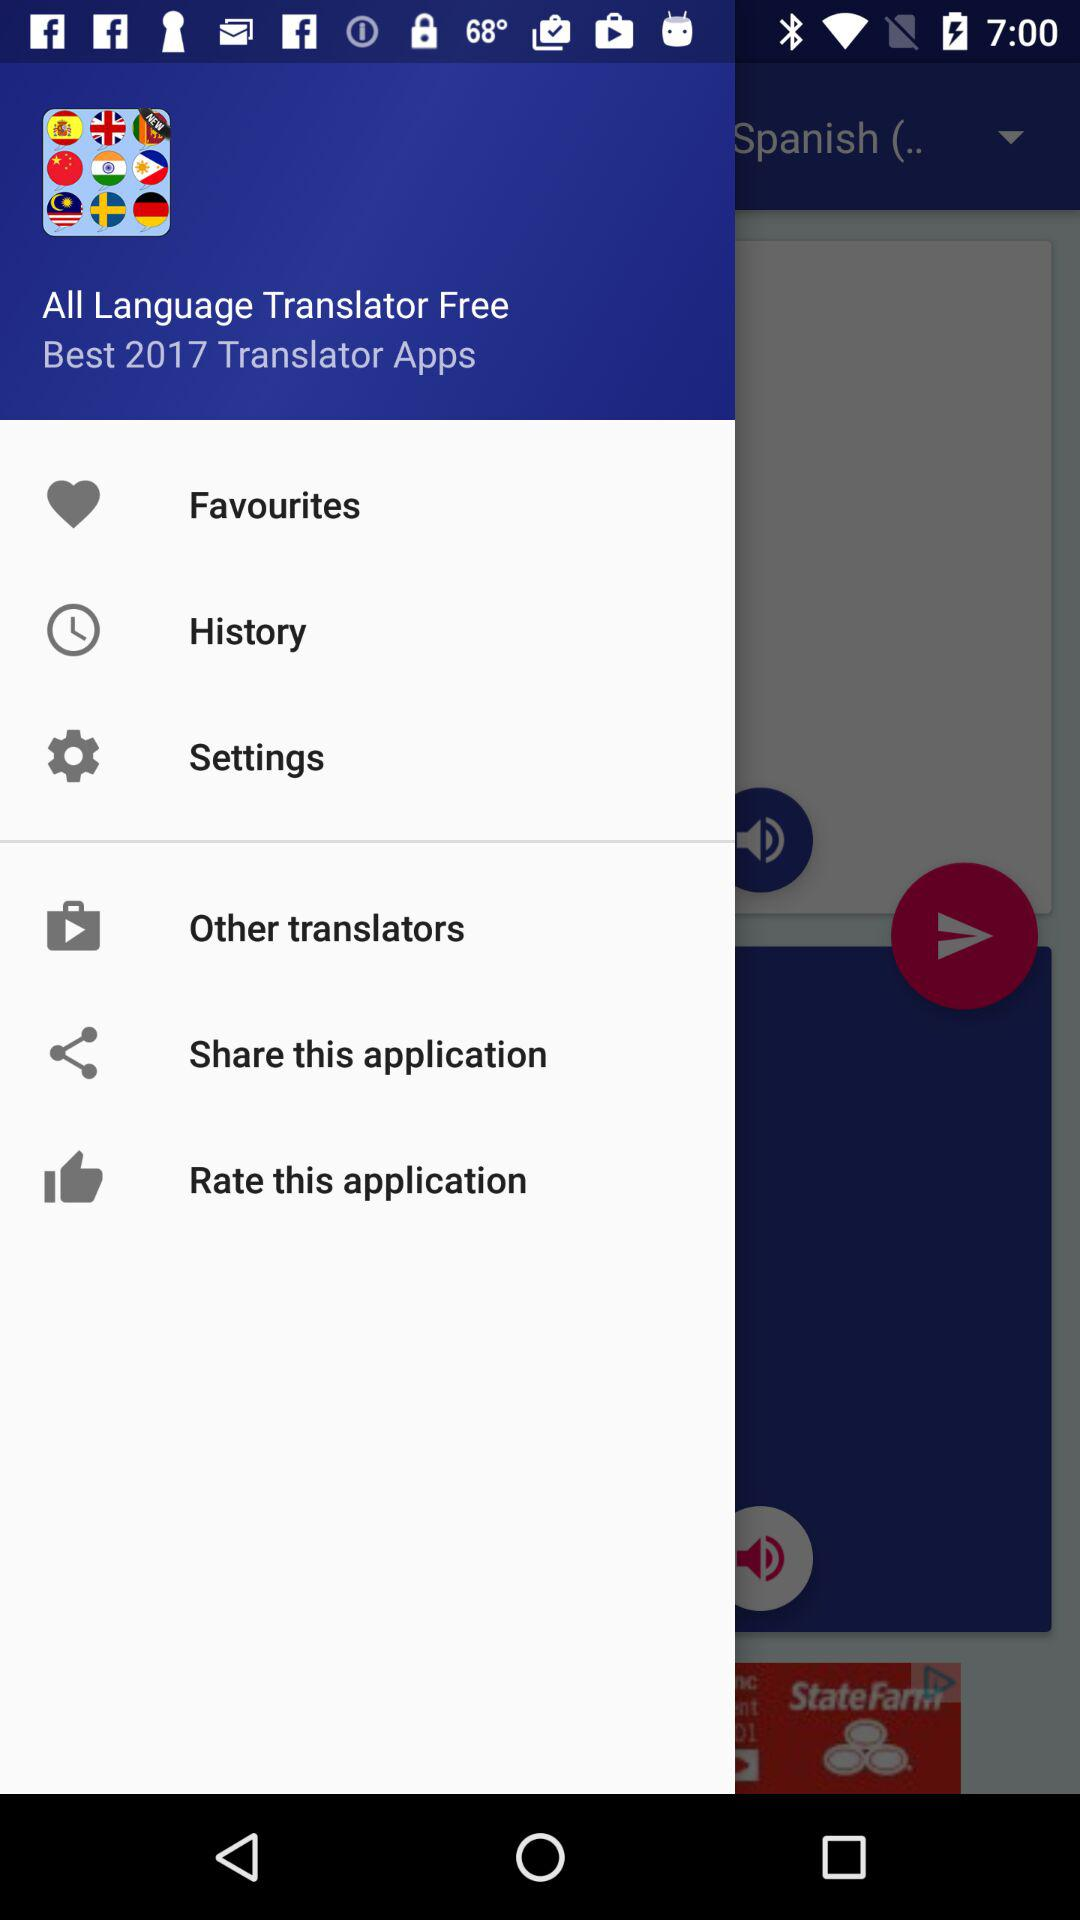What is the application name? The application name is "All Language Translator Free". 